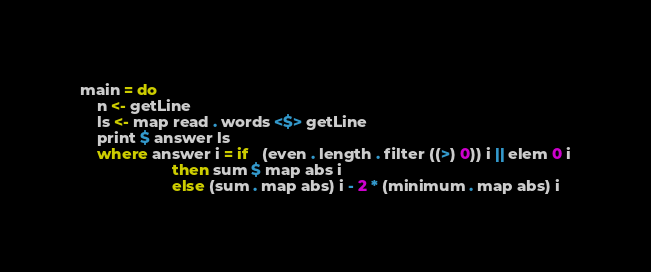<code> <loc_0><loc_0><loc_500><loc_500><_Haskell_>main = do
    n <- getLine
    ls <- map read . words <$> getLine
    print $ answer ls
    where answer i = if   (even . length . filter ((>) 0)) i || elem 0 i
                     then sum $ map abs i
                     else (sum . map abs) i - 2 * (minimum . map abs) i
</code> 